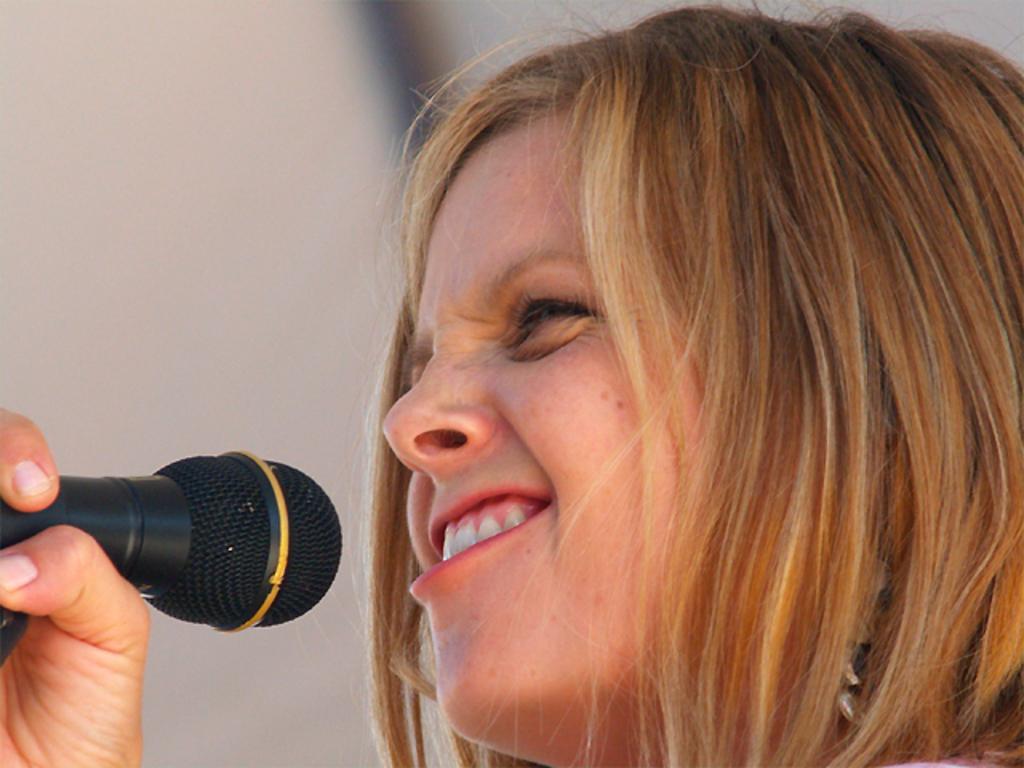Could you give a brief overview of what you see in this image? This woman is holding a mic. Background it is blur. 